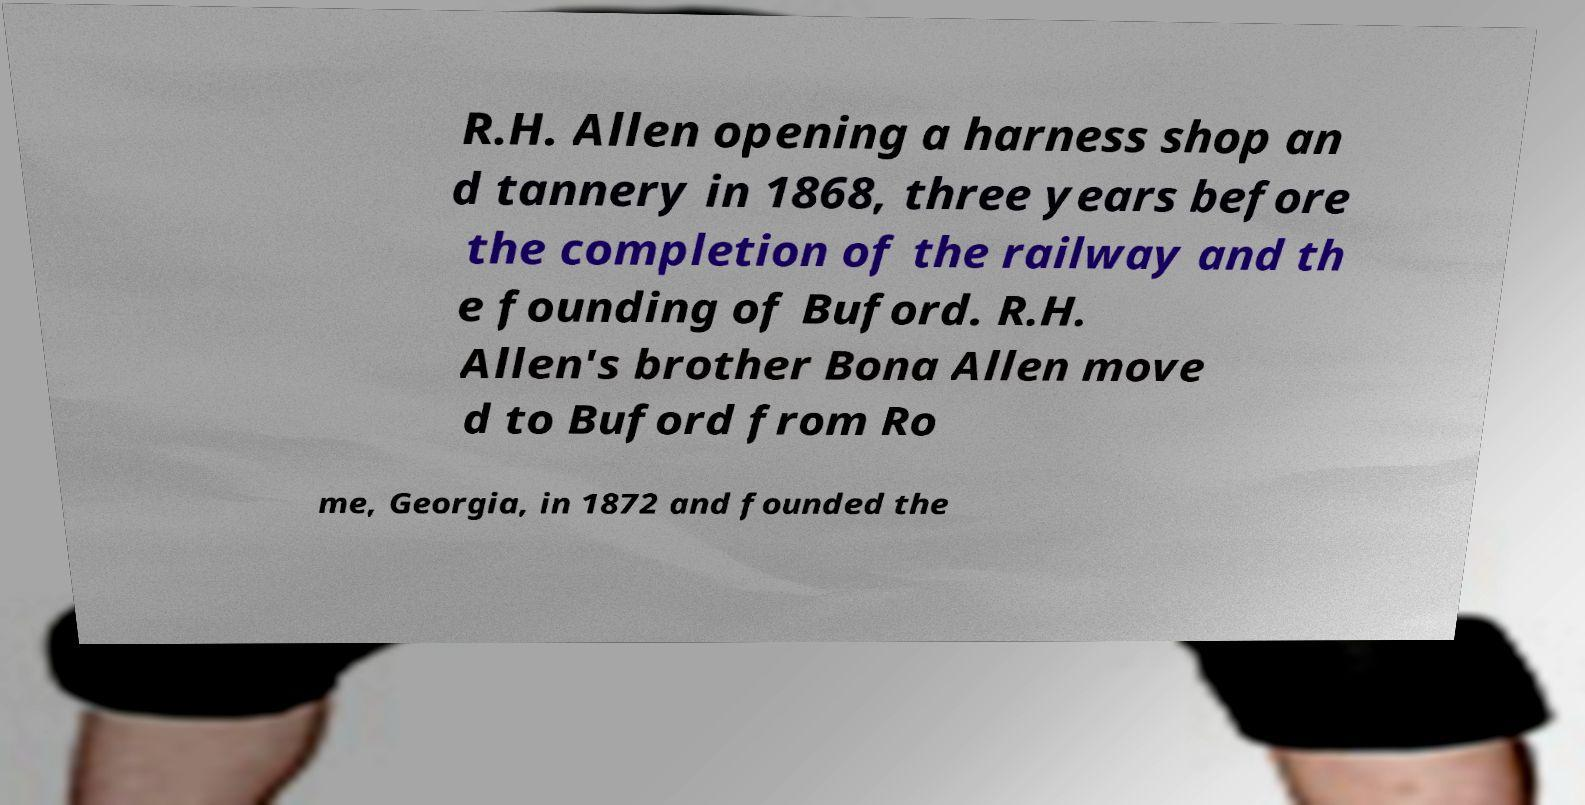I need the written content from this picture converted into text. Can you do that? R.H. Allen opening a harness shop an d tannery in 1868, three years before the completion of the railway and th e founding of Buford. R.H. Allen's brother Bona Allen move d to Buford from Ro me, Georgia, in 1872 and founded the 